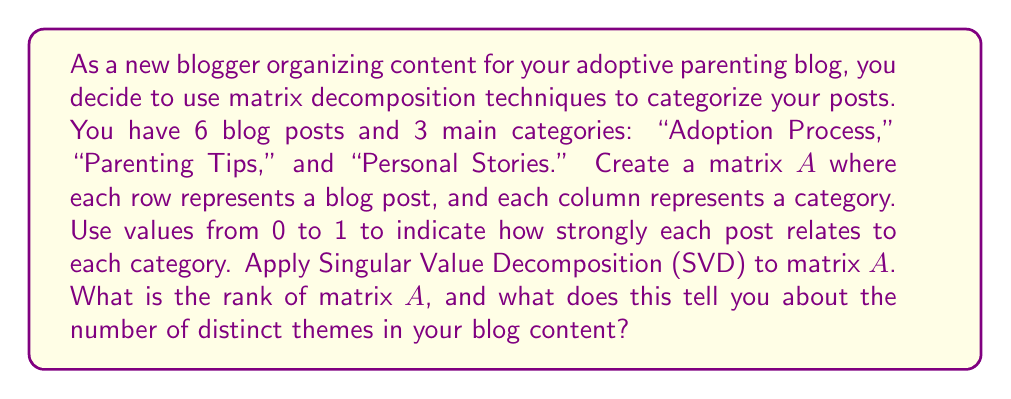Can you answer this question? Let's approach this step-by-step:

1) First, we need to create matrix $A$. For example:

   $$A = \begin{bmatrix}
   0.8 & 0.1 & 0.1 \\
   0.7 & 0.2 & 0.1 \\
   0.1 & 0.7 & 0.2 \\
   0.2 & 0.6 & 0.2 \\
   0.1 & 0.1 & 0.8 \\
   0.2 & 0.2 & 0.6
   \end{bmatrix}$$

2) Singular Value Decomposition (SVD) decomposes $A$ into three matrices:

   $$A = U\Sigma V^T$$

   Where $U$ and $V$ are orthogonal matrices, and $\Sigma$ is a diagonal matrix containing the singular values of $A$.

3) The rank of $A$ is equal to the number of non-zero singular values in $\Sigma$.

4) To find the singular values, we need to calculate $\sqrt{\lambda_i}$, where $\lambda_i$ are the eigenvalues of $A^TA$ or $AA^T$.

5) Calculating $A^TA$:

   $$A^TA = \begin{bmatrix}
   1.19 & 0.52 & 0.49 \\
   0.52 & 1.06 & 0.42 \\
   0.49 & 0.42 & 1.15
   \end{bmatrix}$$

6) Finding the eigenvalues of $A^TA$:

   $\det(A^TA - \lambda I) = 0$

   Solving this equation gives us:
   $\lambda_1 \approx 2.3326$
   $\lambda_2 \approx 0.7674$
   $\lambda_3 \approx 0.3000$

7) The singular values are the square roots of these eigenvalues:

   $\sigma_1 \approx 1.5273$
   $\sigma_2 \approx 0.8760$
   $\sigma_3 \approx 0.5477$

8) Since all singular values are non-zero, the rank of $A$ is 3.

9) This means there are 3 distinct themes in your blog content, corresponding to the 3 categories you initially defined.
Answer: Rank of $A$ is 3, indicating 3 distinct themes in the blog content. 